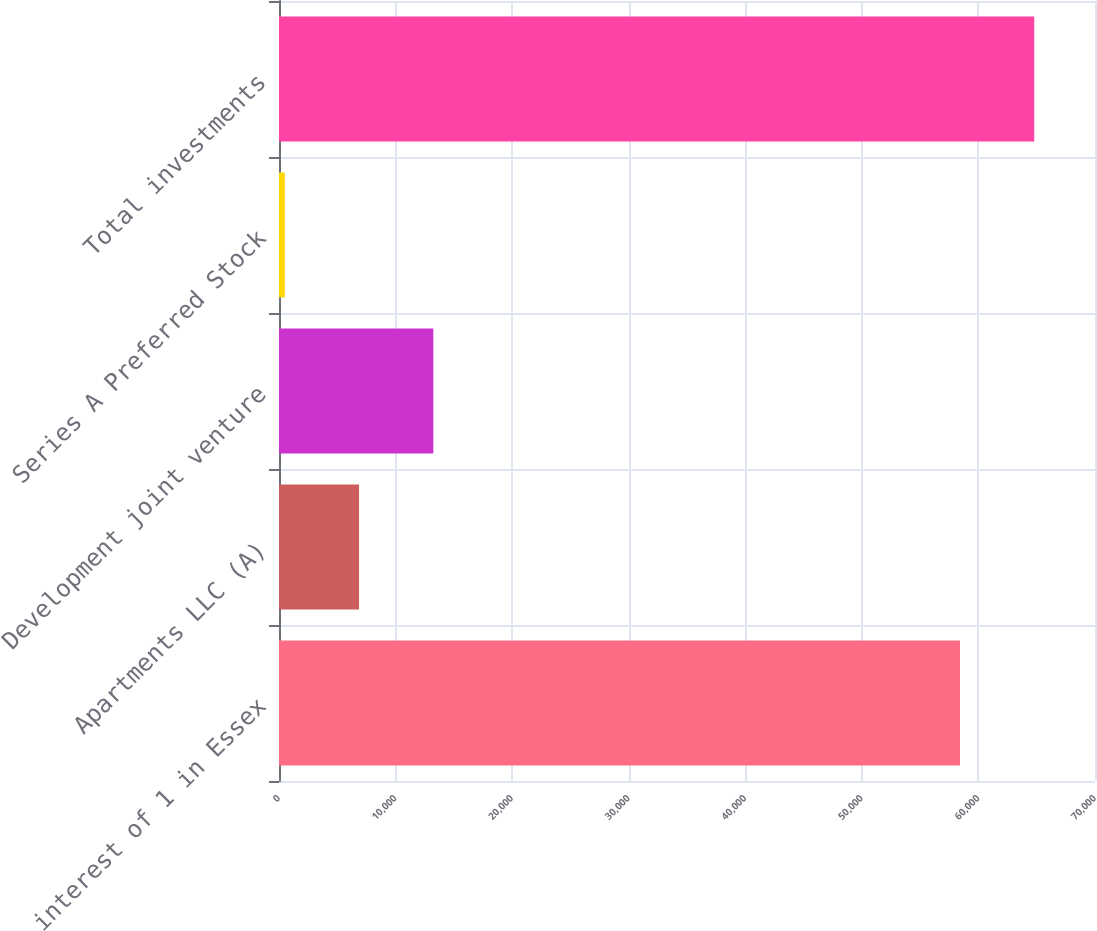<chart> <loc_0><loc_0><loc_500><loc_500><bar_chart><fcel>interest of 1 in Essex<fcel>Apartments LLC (A)<fcel>Development joint venture<fcel>Series A Preferred Stock<fcel>Total investments<nl><fcel>58419<fcel>6869.1<fcel>13238.2<fcel>500<fcel>64788.1<nl></chart> 